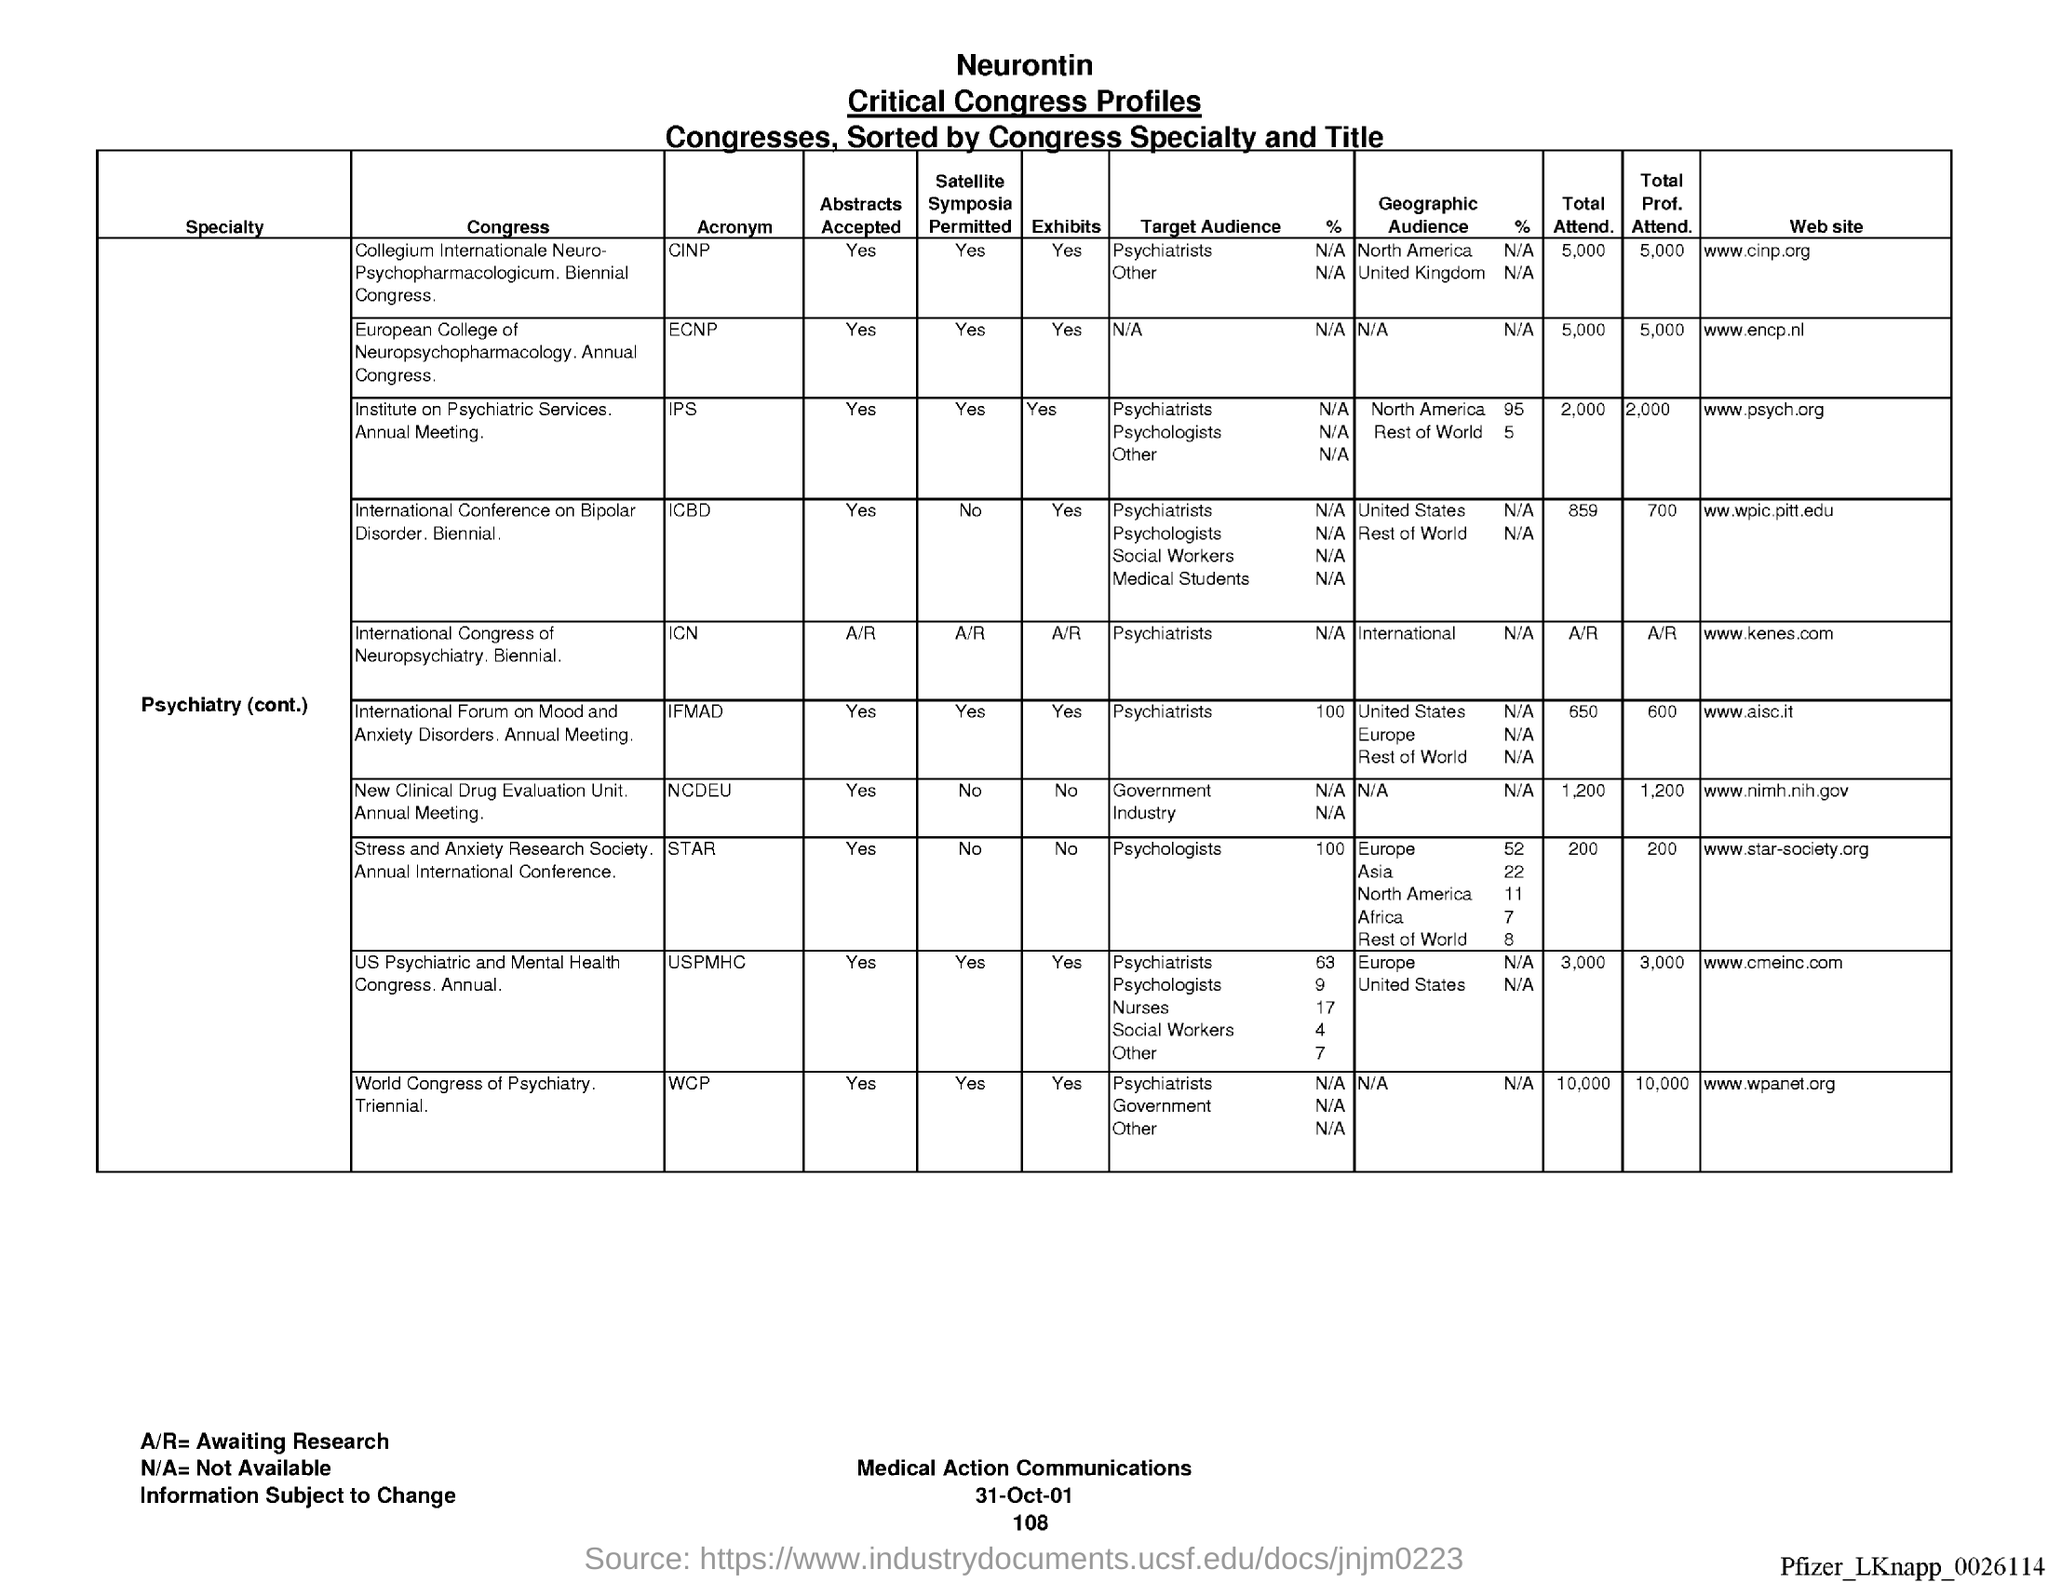Indicate a few pertinent items in this graphic. The website for the Collegium Internationale Neuro-Psychopharmacologicum (CINP) Congress is [www.cinp.org](http://www.cinp.org). The "Total Attend." given for the Collegium Internationale Neuro-Psychopharmacologicum Congress was 5,000 attendees. The International Congress of Neuropsychiatry, referred to as the "ICN," is an important event in the field of neuropsychiatry. The table shows profiles of individuals with neurontin critical congress profiles. The first column heading is "Specialty. 